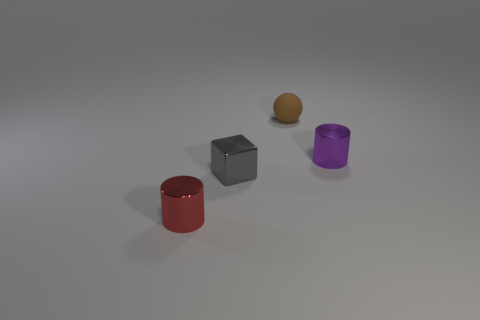What colors are the objects in the image? The image shows objects in various colors: a red cylinder, a silver metal cube, a golden sphere, and a purple cylinder. 